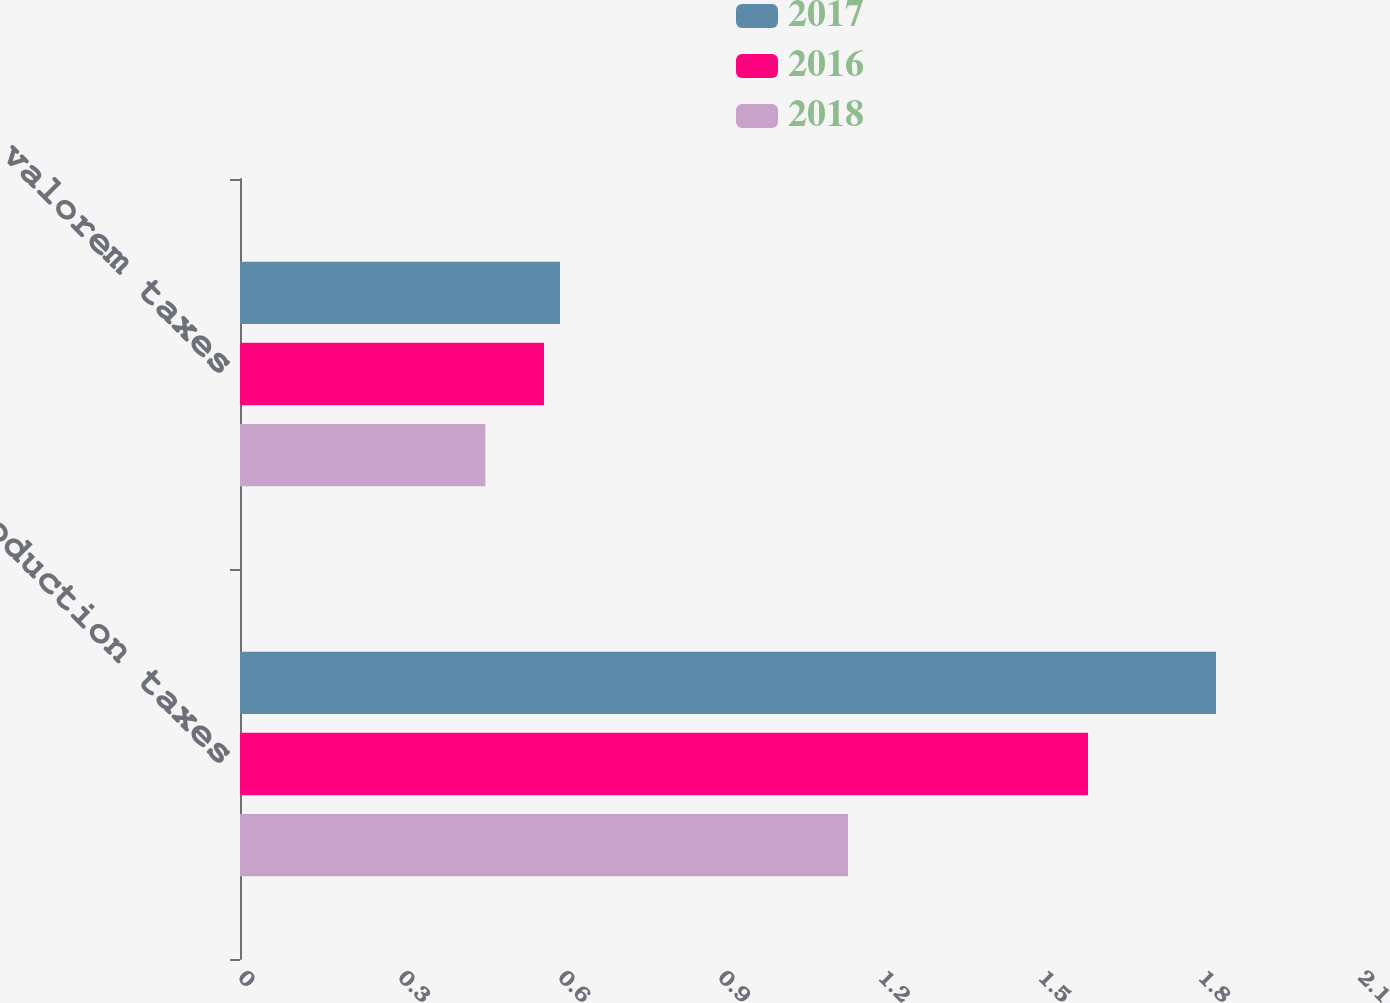Convert chart to OTSL. <chart><loc_0><loc_0><loc_500><loc_500><stacked_bar_chart><ecel><fcel>Production taxes<fcel>Ad valorem taxes<nl><fcel>2017<fcel>1.83<fcel>0.6<nl><fcel>2016<fcel>1.59<fcel>0.57<nl><fcel>2018<fcel>1.14<fcel>0.46<nl></chart> 